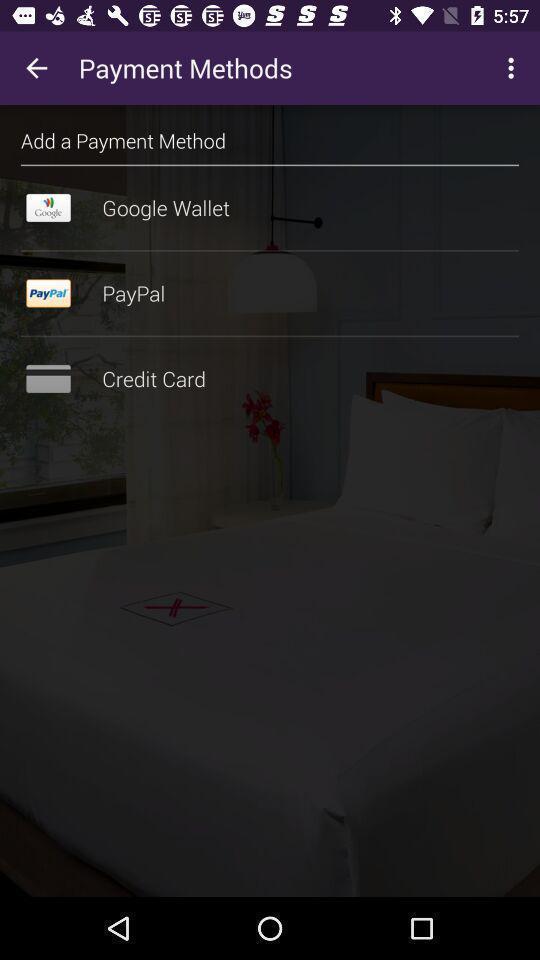Provide a description of this screenshot. Page displaying the various types of payment method. 